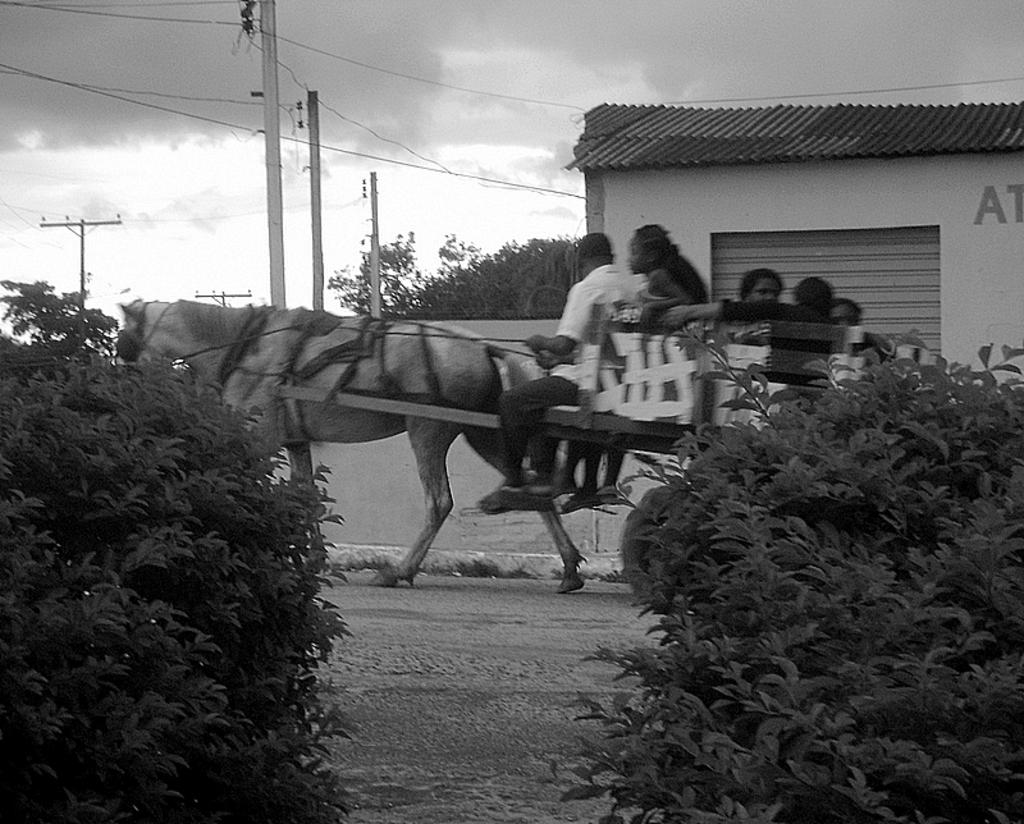What are the people in the image doing with the horse? The people are riding the horse in the image. What other objects or elements can be seen in the image? There are two plants, poles, and a shop visible in the image. What type of fire can be seen coming from the shop in the image? There is no fire present in the image; the shop is not on fire. How many cars are parked near the shop in the image? There are no cars visible in the image; the focus is on the people riding the horse and the surrounding objects and elements. 